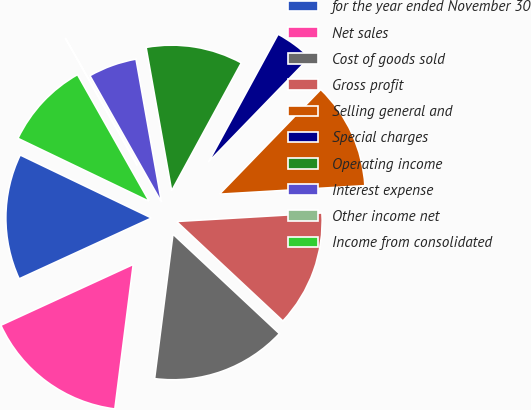<chart> <loc_0><loc_0><loc_500><loc_500><pie_chart><fcel>for the year ended November 30<fcel>Net sales<fcel>Cost of goods sold<fcel>Gross profit<fcel>Selling general and<fcel>Special charges<fcel>Operating income<fcel>Interest expense<fcel>Other income net<fcel>Income from consolidated<nl><fcel>13.98%<fcel>16.13%<fcel>15.05%<fcel>12.9%<fcel>11.83%<fcel>4.3%<fcel>10.75%<fcel>5.38%<fcel>0.01%<fcel>9.68%<nl></chart> 